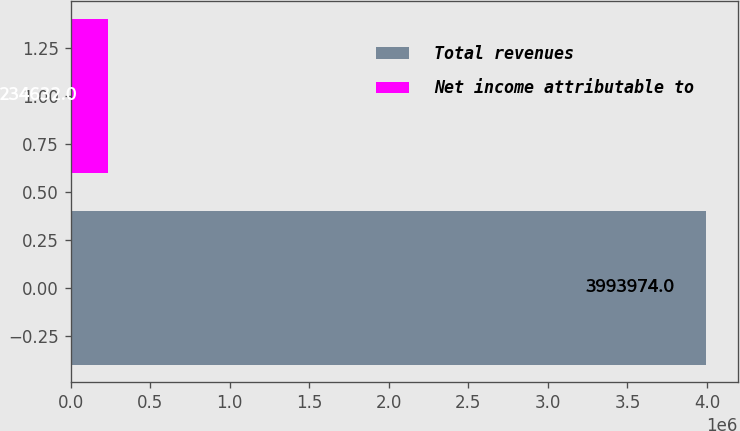Convert chart to OTSL. <chart><loc_0><loc_0><loc_500><loc_500><bar_chart><fcel>Total revenues<fcel>Net income attributable to<nl><fcel>3.99397e+06<fcel>234632<nl></chart> 